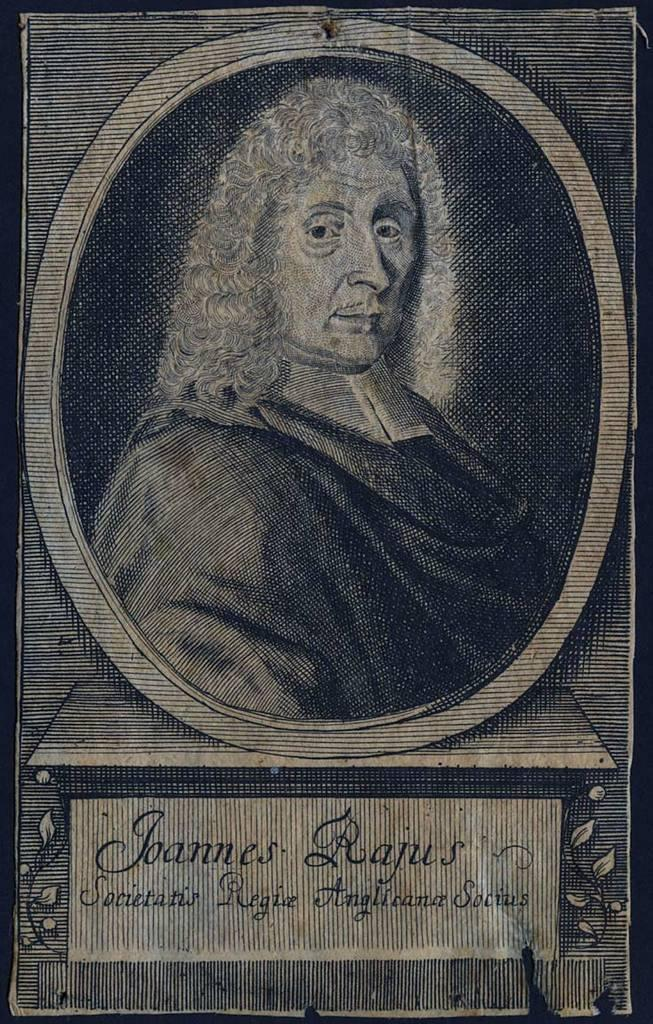What is present in the image? There is a person in the image. Can you describe the person's attire? The person is wearing clothes. What advice does the person in the image give to the viewer? There is no indication in the image that the person is giving advice to the viewer. 